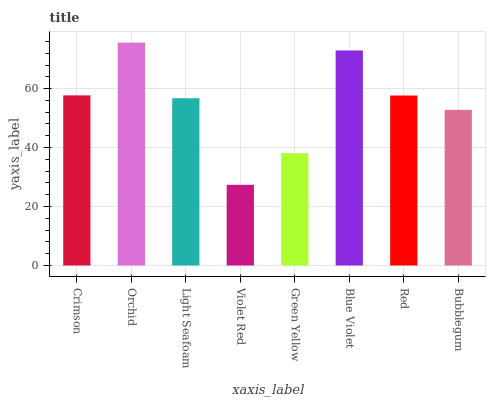Is Violet Red the minimum?
Answer yes or no. Yes. Is Orchid the maximum?
Answer yes or no. Yes. Is Light Seafoam the minimum?
Answer yes or no. No. Is Light Seafoam the maximum?
Answer yes or no. No. Is Orchid greater than Light Seafoam?
Answer yes or no. Yes. Is Light Seafoam less than Orchid?
Answer yes or no. Yes. Is Light Seafoam greater than Orchid?
Answer yes or no. No. Is Orchid less than Light Seafoam?
Answer yes or no. No. Is Red the high median?
Answer yes or no. Yes. Is Light Seafoam the low median?
Answer yes or no. Yes. Is Green Yellow the high median?
Answer yes or no. No. Is Blue Violet the low median?
Answer yes or no. No. 